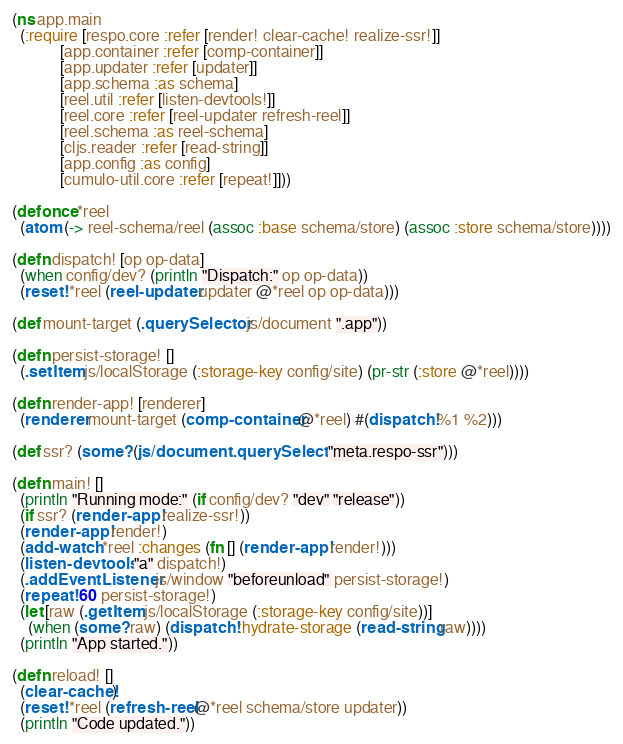Convert code to text. <code><loc_0><loc_0><loc_500><loc_500><_Clojure_>
(ns app.main
  (:require [respo.core :refer [render! clear-cache! realize-ssr!]]
            [app.container :refer [comp-container]]
            [app.updater :refer [updater]]
            [app.schema :as schema]
            [reel.util :refer [listen-devtools!]]
            [reel.core :refer [reel-updater refresh-reel]]
            [reel.schema :as reel-schema]
            [cljs.reader :refer [read-string]]
            [app.config :as config]
            [cumulo-util.core :refer [repeat!]]))

(defonce *reel
  (atom (-> reel-schema/reel (assoc :base schema/store) (assoc :store schema/store))))

(defn dispatch! [op op-data]
  (when config/dev? (println "Dispatch:" op op-data))
  (reset! *reel (reel-updater updater @*reel op op-data)))

(def mount-target (.querySelector js/document ".app"))

(defn persist-storage! []
  (.setItem js/localStorage (:storage-key config/site) (pr-str (:store @*reel))))

(defn render-app! [renderer]
  (renderer mount-target (comp-container @*reel) #(dispatch! %1 %2)))

(def ssr? (some? (js/document.querySelector "meta.respo-ssr")))

(defn main! []
  (println "Running mode:" (if config/dev? "dev" "release"))
  (if ssr? (render-app! realize-ssr!))
  (render-app! render!)
  (add-watch *reel :changes (fn [] (render-app! render!)))
  (listen-devtools! "a" dispatch!)
  (.addEventListener js/window "beforeunload" persist-storage!)
  (repeat! 60 persist-storage!)
  (let [raw (.getItem js/localStorage (:storage-key config/site))]
    (when (some? raw) (dispatch! :hydrate-storage (read-string raw))))
  (println "App started."))

(defn reload! []
  (clear-cache!)
  (reset! *reel (refresh-reel @*reel schema/store updater))
  (println "Code updated."))
</code> 